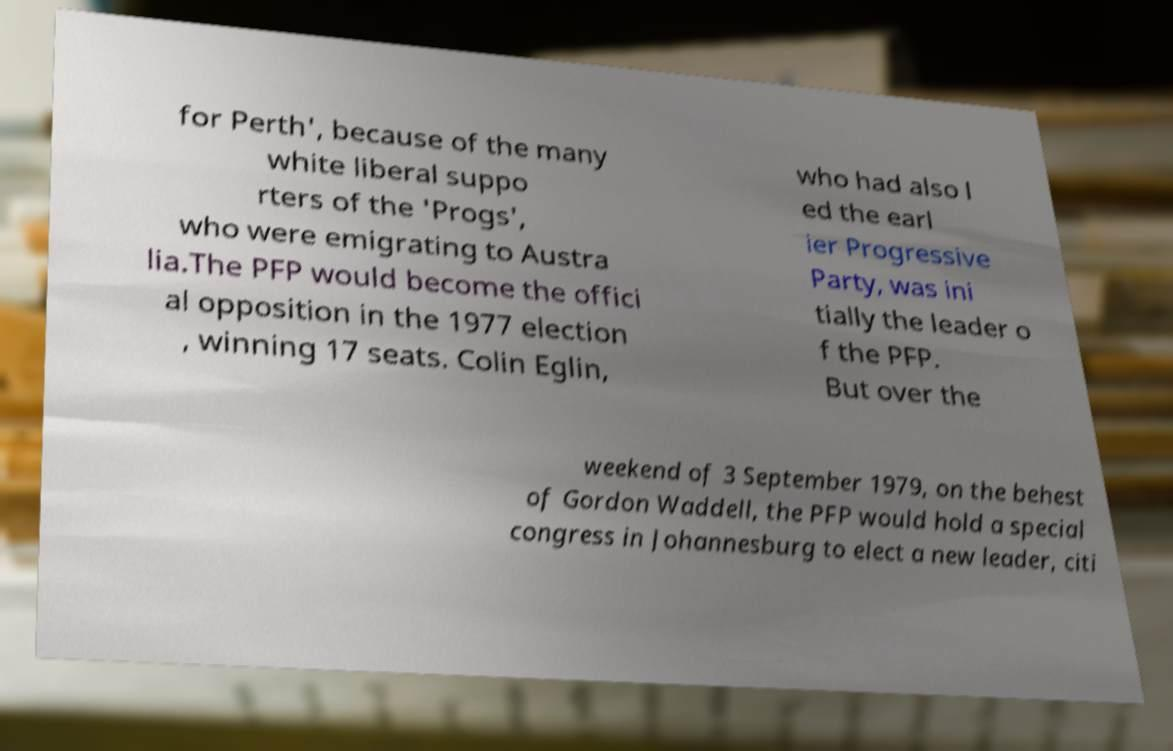Please read and relay the text visible in this image. What does it say? for Perth', because of the many white liberal suppo rters of the 'Progs', who were emigrating to Austra lia.The PFP would become the offici al opposition in the 1977 election , winning 17 seats. Colin Eglin, who had also l ed the earl ier Progressive Party, was ini tially the leader o f the PFP. But over the weekend of 3 September 1979, on the behest of Gordon Waddell, the PFP would hold a special congress in Johannesburg to elect a new leader, citi 